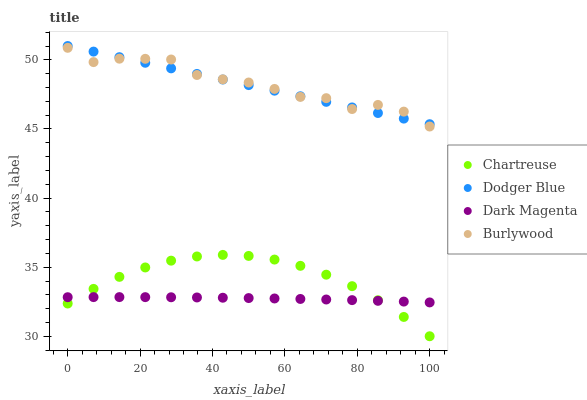Does Dark Magenta have the minimum area under the curve?
Answer yes or no. Yes. Does Burlywood have the maximum area under the curve?
Answer yes or no. Yes. Does Chartreuse have the minimum area under the curve?
Answer yes or no. No. Does Chartreuse have the maximum area under the curve?
Answer yes or no. No. Is Dodger Blue the smoothest?
Answer yes or no. Yes. Is Burlywood the roughest?
Answer yes or no. Yes. Is Chartreuse the smoothest?
Answer yes or no. No. Is Chartreuse the roughest?
Answer yes or no. No. Does Chartreuse have the lowest value?
Answer yes or no. Yes. Does Dodger Blue have the lowest value?
Answer yes or no. No. Does Dodger Blue have the highest value?
Answer yes or no. Yes. Does Chartreuse have the highest value?
Answer yes or no. No. Is Dark Magenta less than Dodger Blue?
Answer yes or no. Yes. Is Burlywood greater than Dark Magenta?
Answer yes or no. Yes. Does Dodger Blue intersect Burlywood?
Answer yes or no. Yes. Is Dodger Blue less than Burlywood?
Answer yes or no. No. Is Dodger Blue greater than Burlywood?
Answer yes or no. No. Does Dark Magenta intersect Dodger Blue?
Answer yes or no. No. 